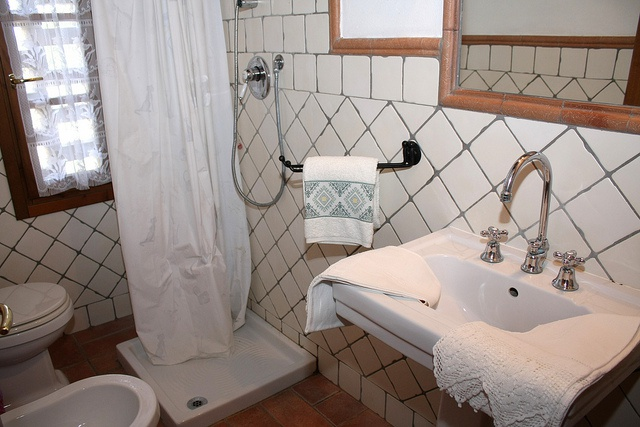Describe the objects in this image and their specific colors. I can see sink in gray, tan, darkgray, and lightgray tones, toilet in gray and black tones, and toilet in gray and darkgray tones in this image. 